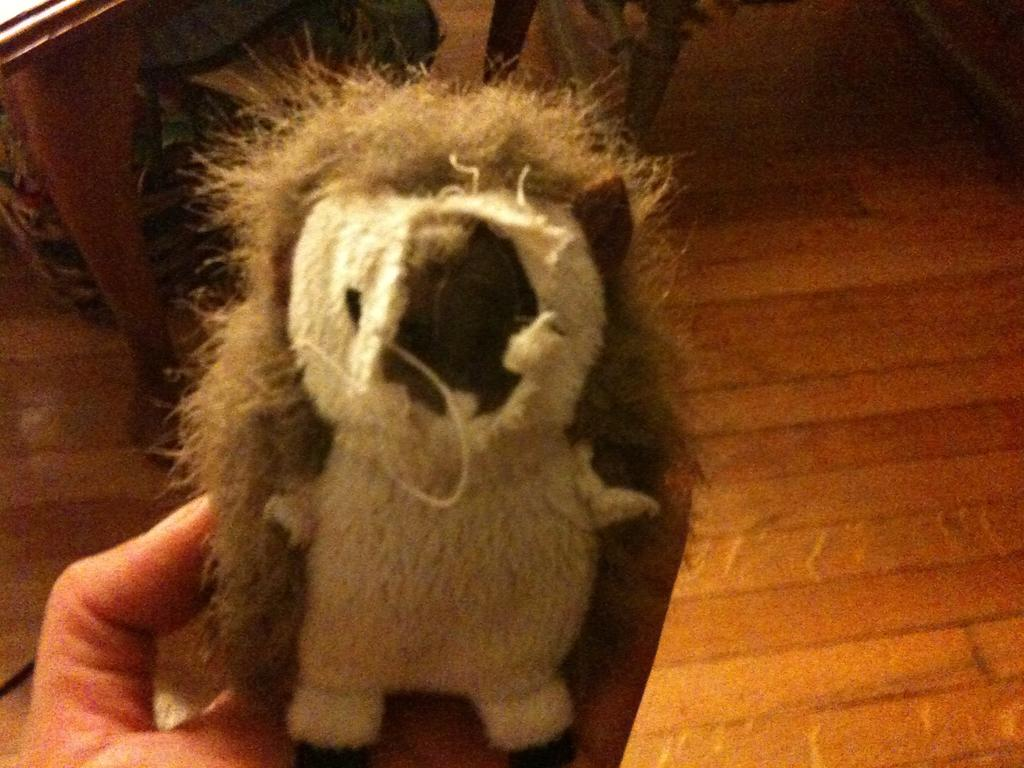What is present in the image? There is a person in the image. What is the person holding? The person is holding a toy. What type of chalk is being used to draw on the person's body in the image? There is no chalk or drawing on the person's body in the image. 